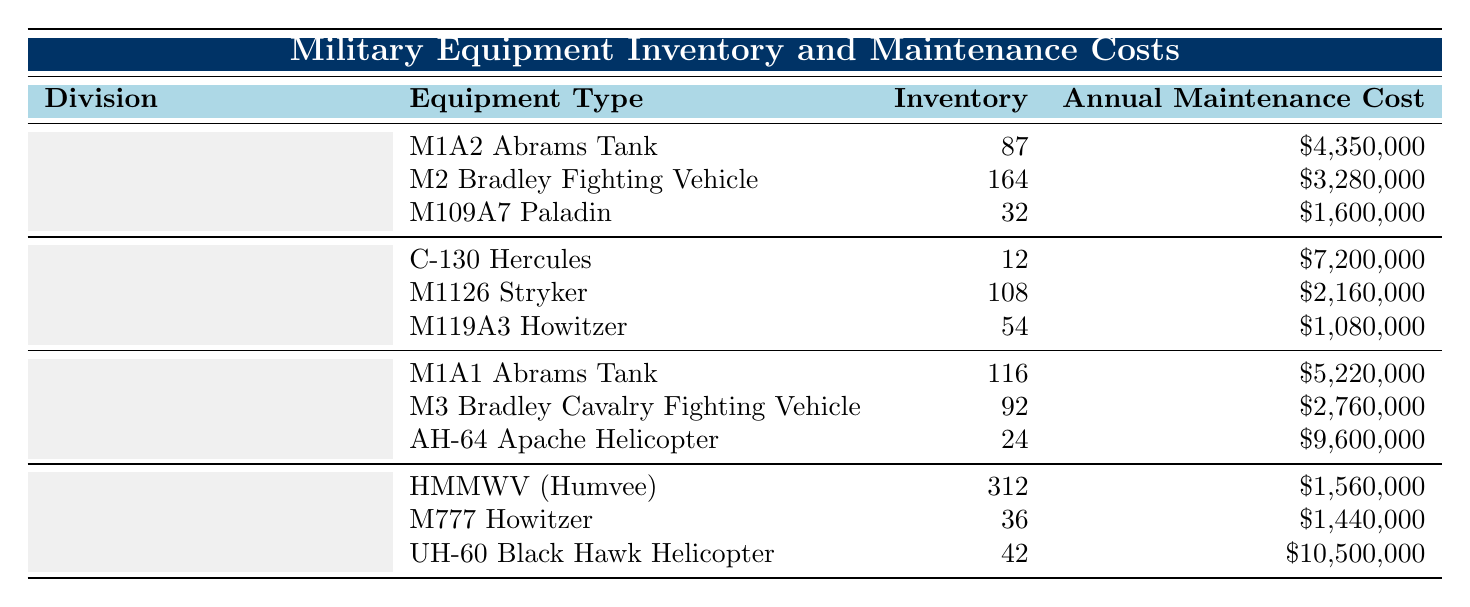What is the annual maintenance cost of the C-130 Hercules? The C-130 Hercules is listed under the 82nd Airborne Division. Its annual maintenance cost is given directly in the table.
Answer: $7,200,000 How many M2 Bradley Fighting Vehicles does the 1st Infantry Division have? The quantity for M2 Bradley Fighting Vehicles is explicitly stated under the 1st Infantry Division in the table.
Answer: 164 What is the total inventory of tanks between the 1st Infantry Division and the 3rd Armored Division? The total tanks consist of 87 M1A2 Abrams Tanks from the 1st Infantry Division and 116 M1A1 Abrams Tanks from the 3rd Armored Division. Adding them gives 87 + 116 = 203.
Answer: 203 Which division has the highest annual maintenance cost for its equipment? To find the division with the highest maintenance cost, we compare the total maintenance costs for each division. After calculating, the 3rd Armored Division, with AH-64 Apache Helicopter and M1A1 Abrams Tank, has the highest combined cost of $17,580,000.
Answer: 3rd Armored Division What is the average annual maintenance cost for equipment in the 10th Mountain Division? The total annual maintenance cost for the 10th Mountain Division is $1,560,000 (HMMWV) + $1,440,000 (M777 Howitzer) + $10,500,000 (UH-60 Black Hawk) = $13,500,000. There are three pieces of equipment, so the average is $13,500,000 / 3 = $4,500,000.
Answer: $4,500,000 Does the 1st Infantry Division have more total maintenance costs than the 82nd Airborne Division? First, compute the annual maintenance costs: 1st Infantry Division totals $9,230,000 ($4,350,000 + $3,280,000 + $1,600,000) and 82nd Airborne Division totals $10,440,000 ($7,200,000 + $2,160,000 + $1,080,000). Comparing these totals shows that the 1st Infantry Division has less maintenance costs.
Answer: No What is the total inventory of equipment across all divisions? To get the total inventory, sum all equipment inventories: 87 (M1A2) + 164 (M2) + 32 (M109A7) + 12 (C-130) + 108 (M1126) + 54 (M119A3) + 116 (M1A1) + 92 (M3) + 24 (AH-64) + 312 (HMMWV) + 36 (M777) + 42 (UH-60) =  1,031.
Answer: 1,031 How much does the 10th Mountain Division spend on maintenance for helicopters? The 10th Mountain Division maintains one UH-60 Black Hawk Helicopter with a cost of $10,500,000 and none for HMMWV and M777 Howitzer because they are not helicopters. Therefore, the total maintenance for helicopters is simply the cost for UH-60.
Answer: $10,500,000 Which equipment type has the lowest annual maintenance cost in the 3rd Armored Division? The annual maintenance costs for the 3rd Armored Division are $5,220,000 (M1A1), $2,760,000 (M3), and $9,600,000 (AH-64). The lowest value is $2,760,000 for the M3 Bradley Cavalry Fighting Vehicle.
Answer: M3 Bradley Cavalry Fighting Vehicle What is the difference in inventory between the HMMWV from the 10th Mountain Division and the C-130 Hercules from the 82nd Airborne Division? HMMWV has an inventory of 312 and C-130 Hercules has an inventory of 12. The difference is calculated by subtracting: 312 - 12 = 300.
Answer: 300 